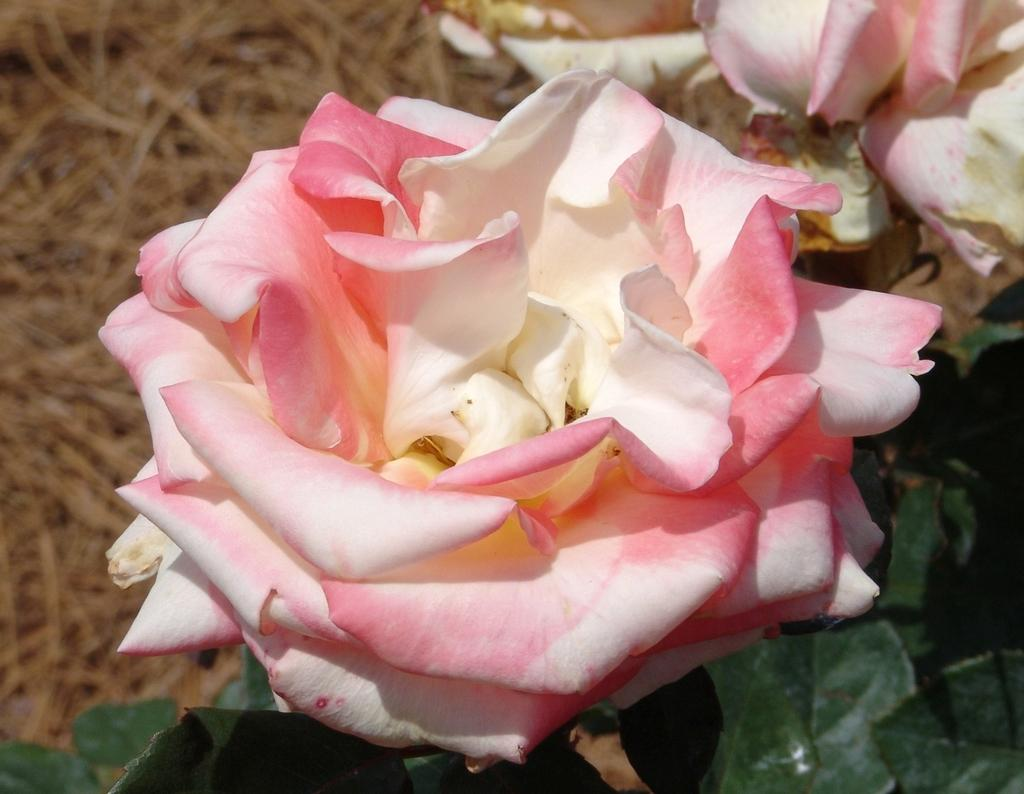What type of vegetation can be seen in the image? There are flowers, plants, and grass in the image. Can you describe the background of the image? The background of the image is blurred. How many oranges are hanging from the flowers in the image? There are no oranges present in the image; it features flowers, plants, and grass. What type of treatment is being applied to the plants in the image? There is no treatment being applied to the plants in the image; the image simply shows them in their natural state. 